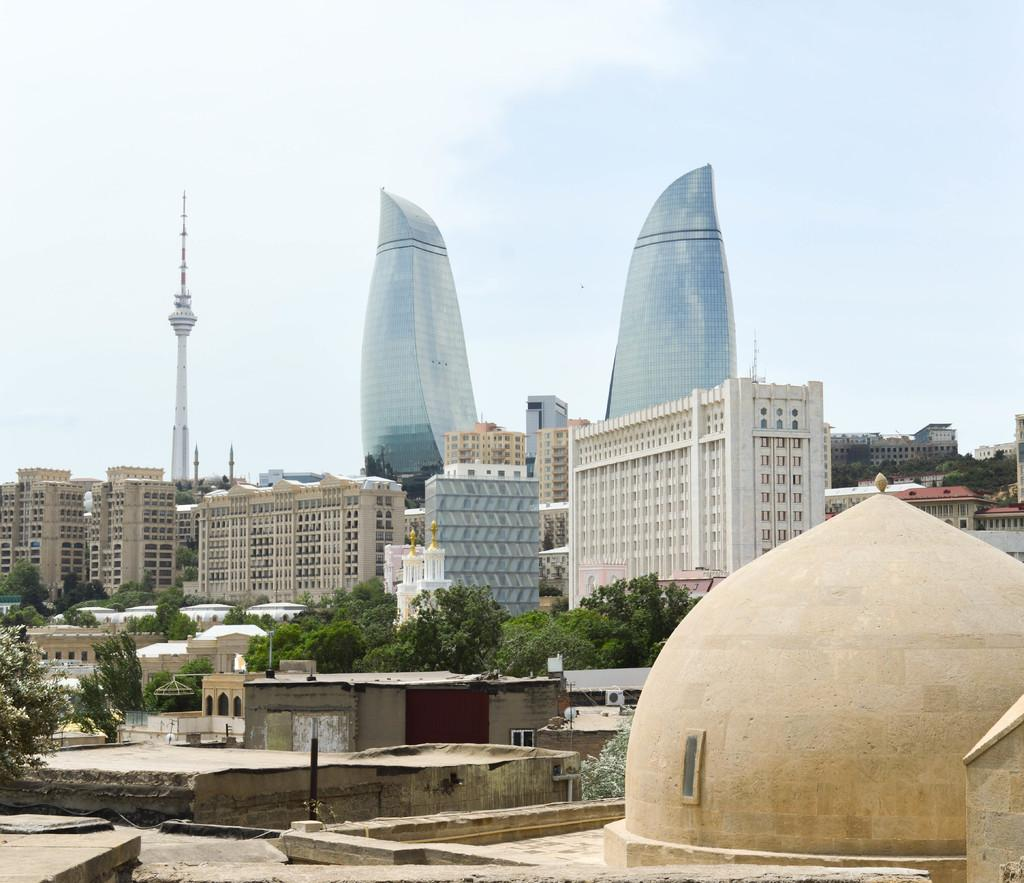What type of structures can be seen in the image? There are buildings, a tower, and a dome structure in the image. What type of vegetation is present in the image? There are trees in the image. What is visible at the top of the image? The sky is visible at the top of the image. Where is the dome structure located in the image? The dome structure is on the right side of the image. Can you tell me who won the fight depicted in the image? There is no fight depicted in the image; it features buildings, trees, a tower, and a dome structure. What is the comparison between the two stages shown in the image? There are no stages present in the image; it only contains buildings, trees, a tower, and a dome structure. 